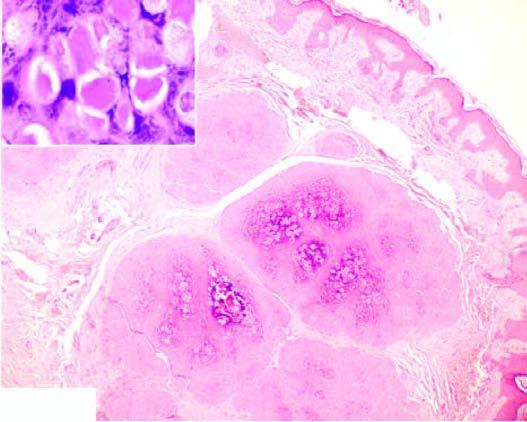does peripheral blood film showing marked neutrophilic leucocytosis show close-up view of molluscum bodies?
Answer the question using a single word or phrase. No 